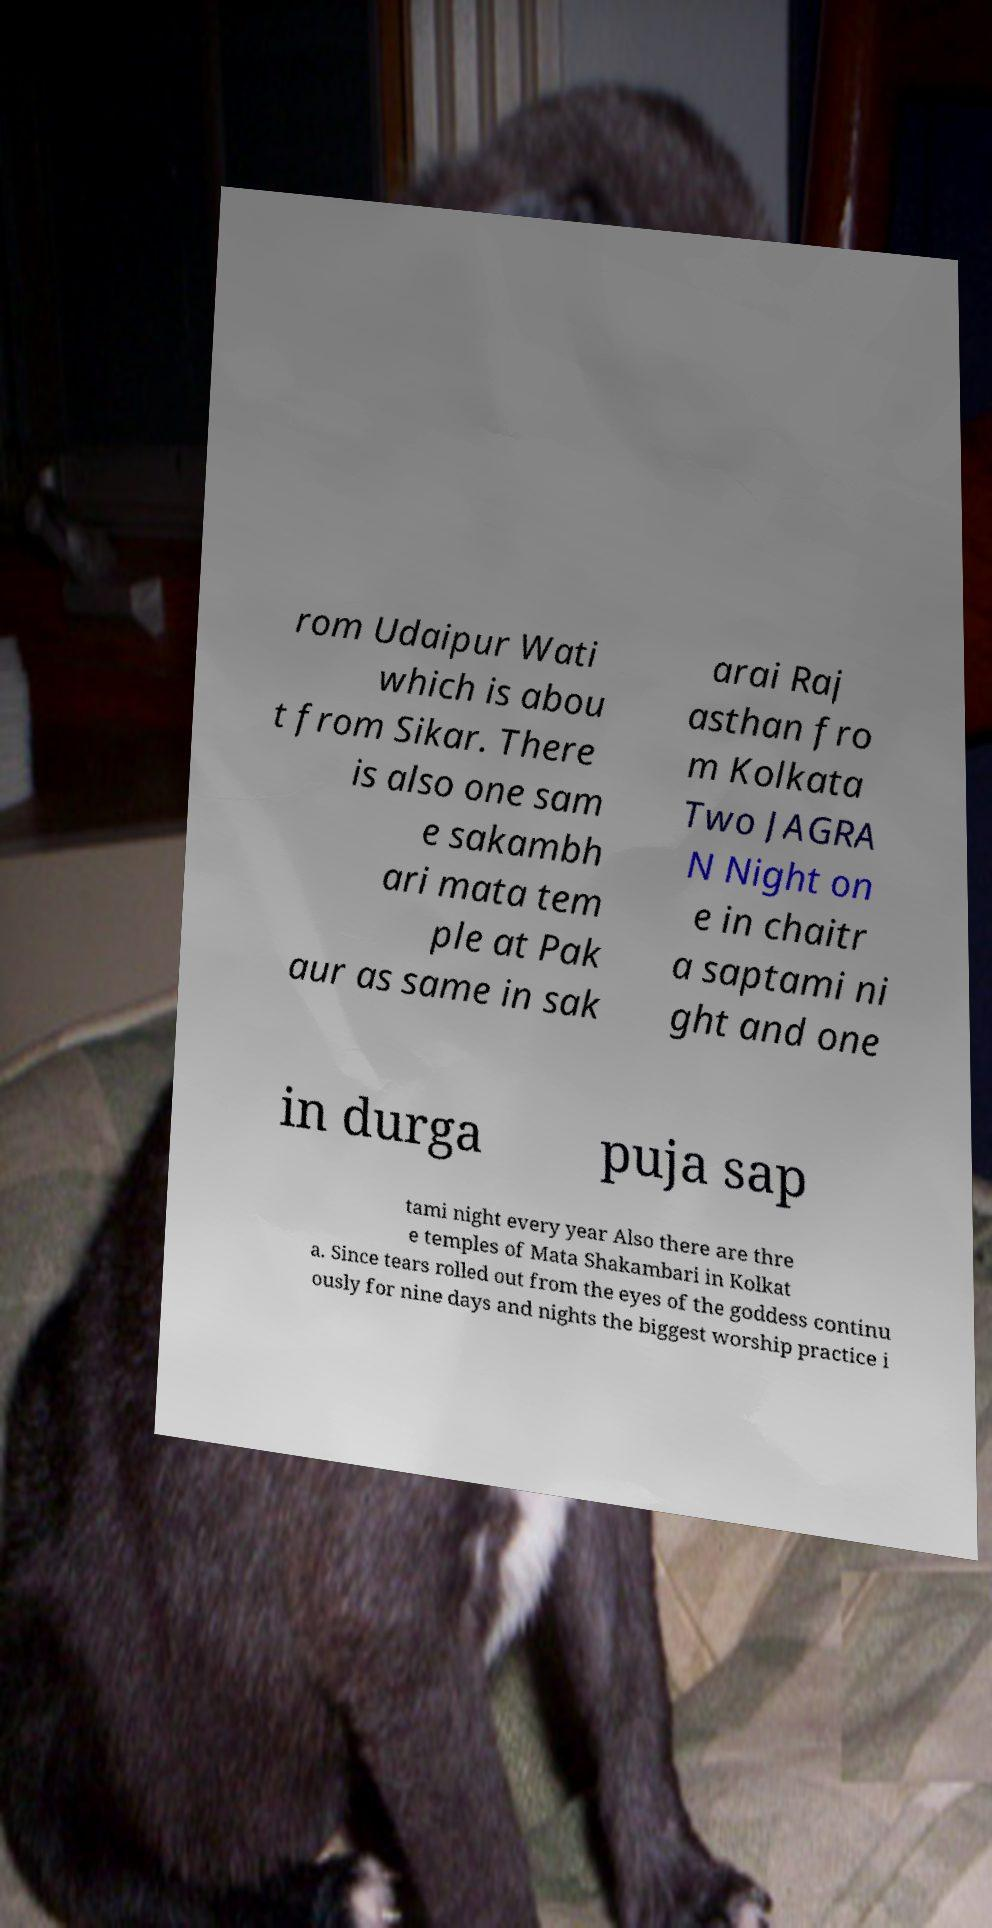I need the written content from this picture converted into text. Can you do that? rom Udaipur Wati which is abou t from Sikar. There is also one sam e sakambh ari mata tem ple at Pak aur as same in sak arai Raj asthan fro m Kolkata Two JAGRA N Night on e in chaitr a saptami ni ght and one in durga puja sap tami night every year Also there are thre e temples of Mata Shakambari in Kolkat a. Since tears rolled out from the eyes of the goddess continu ously for nine days and nights the biggest worship practice i 